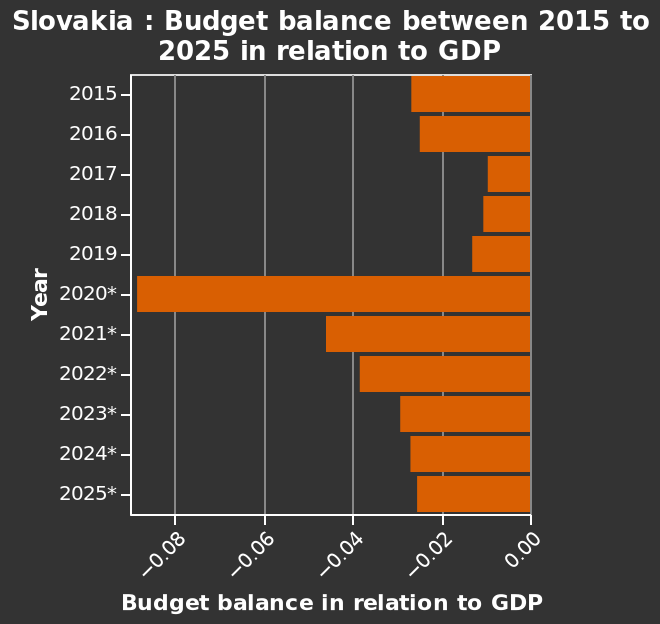<image>
Offer a thorough analysis of the image. A sharp decline in 2017/2018 with an incline in 2019. It peaks in 2020. Moving forward we see a steady decline. 